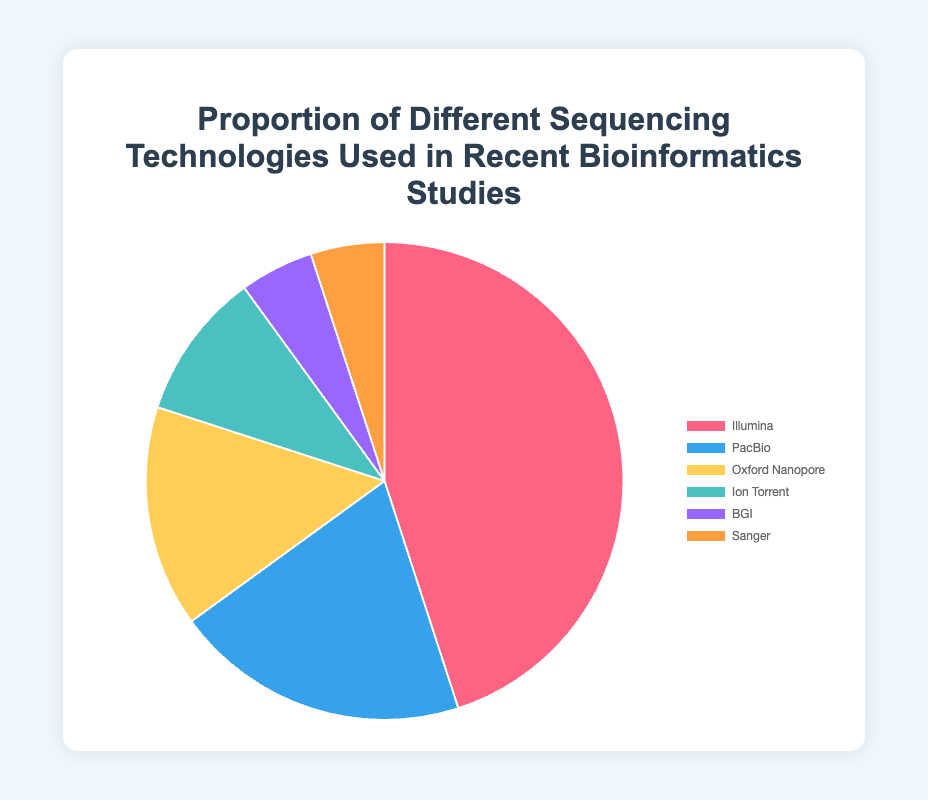Which sequencing technology is used the most in recent bioinformatics studies? The pie chart shows different sequencing technologies. The largest portion is "Illumina" with 45%, indicating it's the most used technology.
Answer: Illumina How much more is Illumina used compared to PacBio? Illumina has a 45% usage, while PacBio has 20%. The difference is 45% - 20% = 25%.
Answer: 25% What is the total proportion of the less common technologies (BGI and Sanger)? BGI and Sanger both have a 5% usage each. The sum is 5% + 5% = 10%.
Answer: 10% Which technologies together make up 30% of the studies? PacBio and Oxford Nanopore have 20% and 15%, respectively. Summing their proportions: 20% + 15% = 35%. Since it exceeds 30%, check another combination: Oxford Nanopore (15%) + Ion Torrent (10%) = 25%. Another: Ion Torrent (10%) + BGI (5%) + Sanger (5%) = 20%. Thus, PacBio (20%) and Ion Torrent (10%) sum to exactly 30%.
Answer: PacBio and Ion Torrent What is the difference in usage between Oxford Nanopore and Ion Torrent? Oxford Nanopore has a 15% usage, while Ion Torrent has 10%. The difference is 15% - 10% = 5%.
Answer: 5% If you combine the usage of the two least used technologies, how does their combined proportion compare to Ion Torrent? The least used technologies are BGI and Sanger, each with 5%. Combined, they make up 5% + 5% = 10%, which is equal to the proportion of Ion Torrent.
Answer: Equal Which technology has the smallest usage, and what is its proportion? The smallest portion in the pie chart represents "Sanger" and "BGI", each with 5%.
Answer: Sanger and BGI, 5% What is the proportion discrepancy between the most and least used sequencing technologies? The most used technology is Illumina at 45%, and the least used are BGI and Sanger at 5%. The discrepancy is 45% - 5% = 40%.
Answer: 40% Are there more studies using Oxford Nanopore than PacBio? PacBio shows a 20% usage while Oxford Nanopore shows 15%. 20% is more than 15%.
Answer: No What is the combined percentage of studies using short-read sequencing technologies (Illumina, BGI) compared to long-read sequencing technologies (PacBio, Oxford Nanopore)? Short-read: Illumina (45%) + BGI (5%) = 50%. Long-read: PacBio (20%) + Oxford Nanopore (15%) = 35%.
Answer: 50% (short-read) vs. 35% (long-read) 